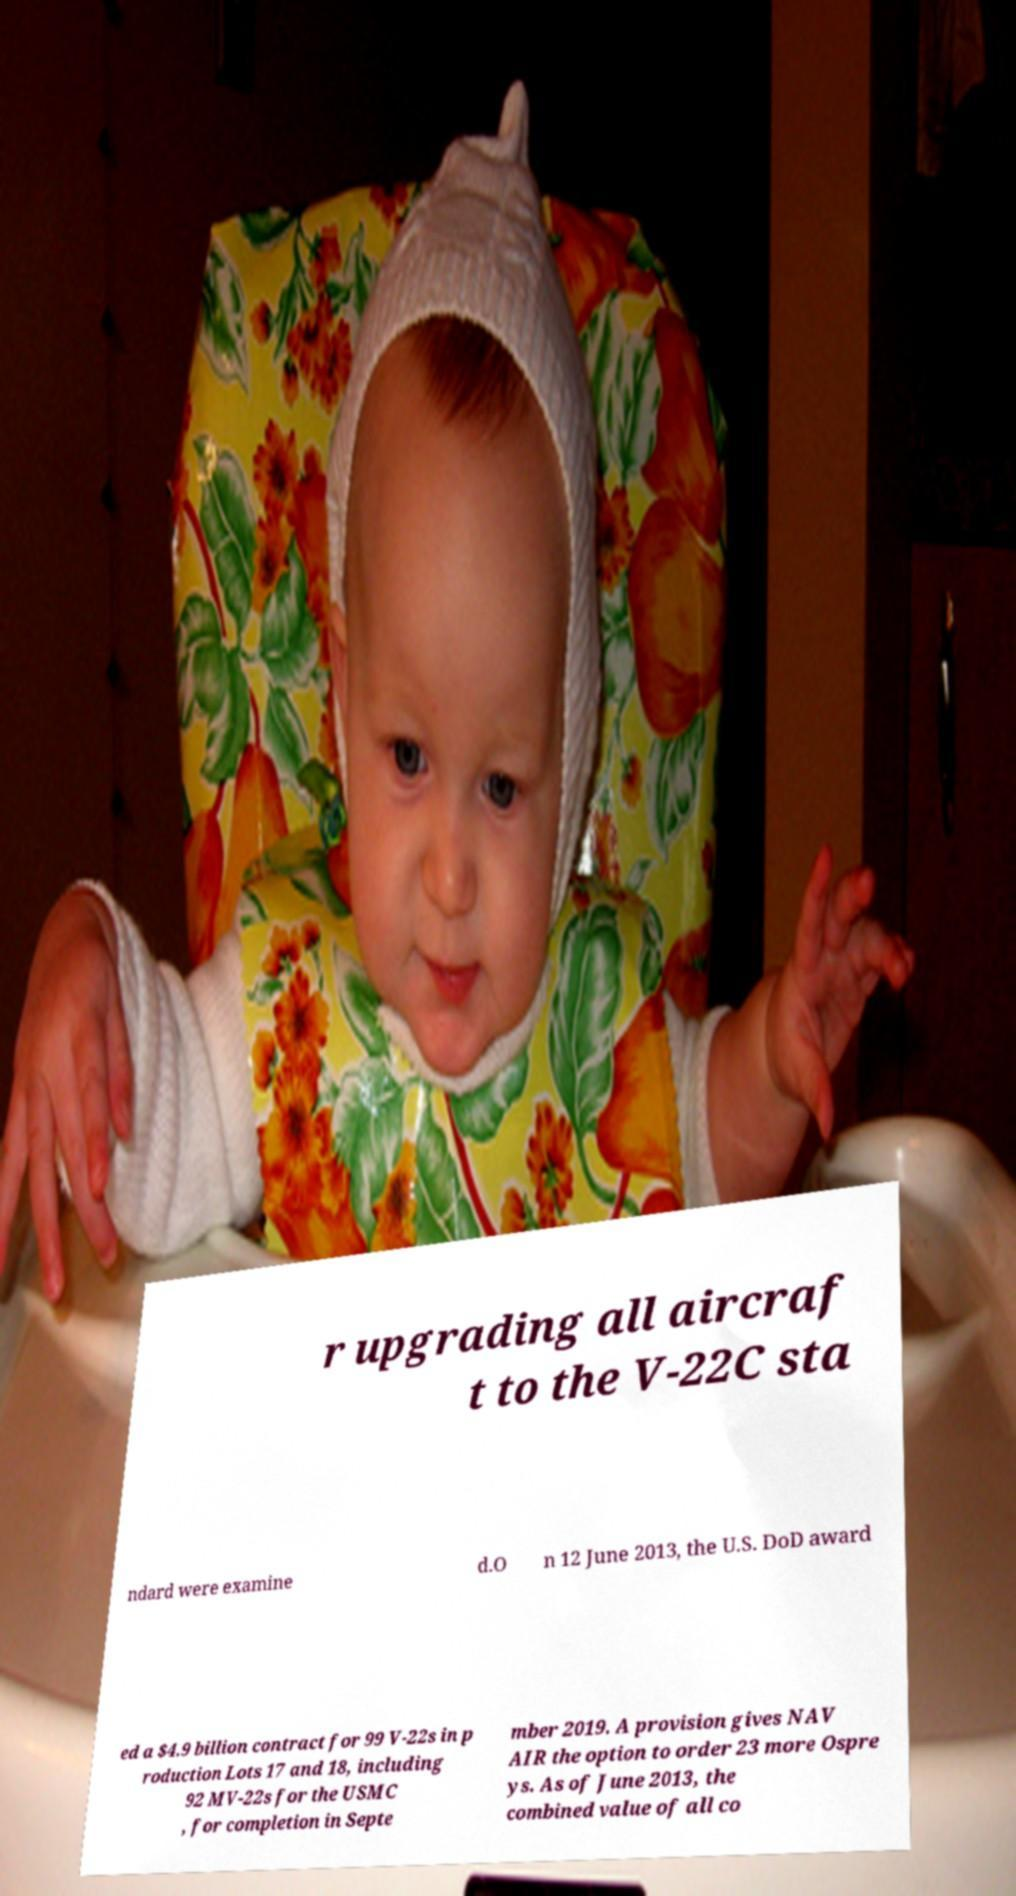Can you accurately transcribe the text from the provided image for me? r upgrading all aircraf t to the V-22C sta ndard were examine d.O n 12 June 2013, the U.S. DoD award ed a $4.9 billion contract for 99 V-22s in p roduction Lots 17 and 18, including 92 MV-22s for the USMC , for completion in Septe mber 2019. A provision gives NAV AIR the option to order 23 more Ospre ys. As of June 2013, the combined value of all co 